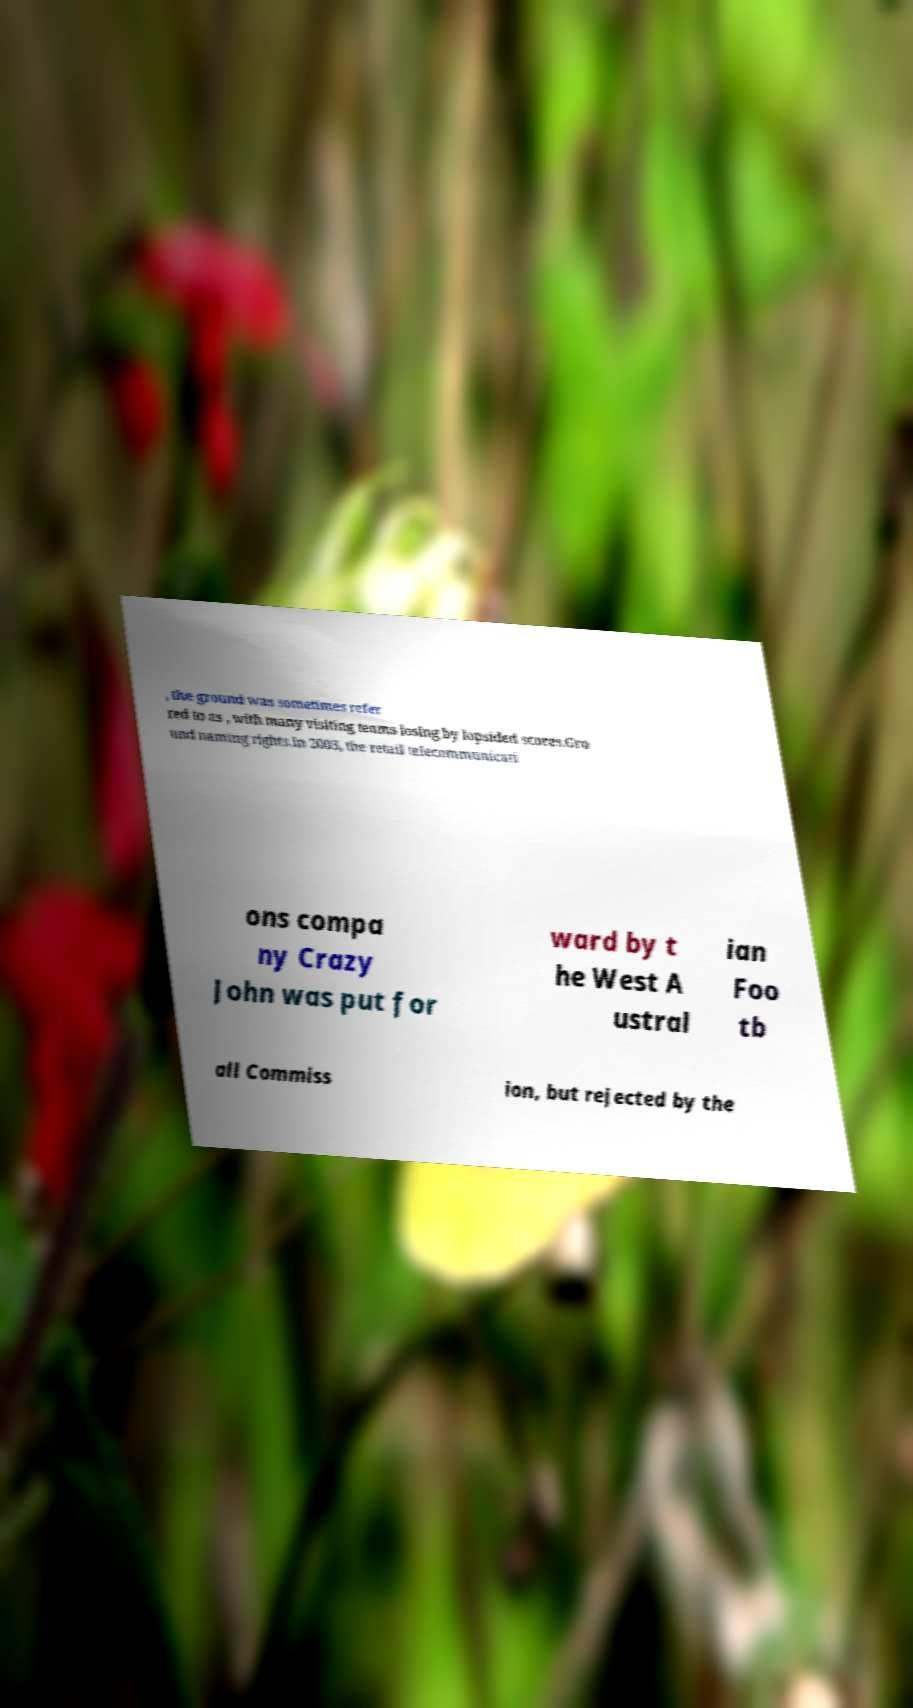I need the written content from this picture converted into text. Can you do that? , the ground was sometimes refer red to as , with many visiting teams losing by lopsided scores.Gro und naming rights.In 2003, the retail telecommunicati ons compa ny Crazy John was put for ward by t he West A ustral ian Foo tb all Commiss ion, but rejected by the 